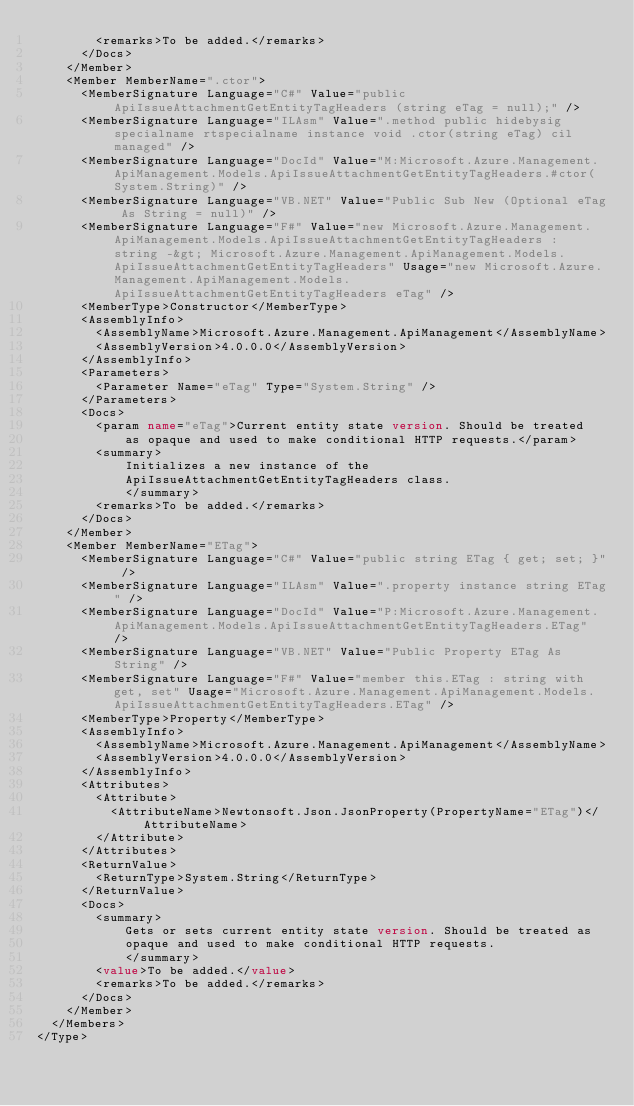Convert code to text. <code><loc_0><loc_0><loc_500><loc_500><_XML_>        <remarks>To be added.</remarks>
      </Docs>
    </Member>
    <Member MemberName=".ctor">
      <MemberSignature Language="C#" Value="public ApiIssueAttachmentGetEntityTagHeaders (string eTag = null);" />
      <MemberSignature Language="ILAsm" Value=".method public hidebysig specialname rtspecialname instance void .ctor(string eTag) cil managed" />
      <MemberSignature Language="DocId" Value="M:Microsoft.Azure.Management.ApiManagement.Models.ApiIssueAttachmentGetEntityTagHeaders.#ctor(System.String)" />
      <MemberSignature Language="VB.NET" Value="Public Sub New (Optional eTag As String = null)" />
      <MemberSignature Language="F#" Value="new Microsoft.Azure.Management.ApiManagement.Models.ApiIssueAttachmentGetEntityTagHeaders : string -&gt; Microsoft.Azure.Management.ApiManagement.Models.ApiIssueAttachmentGetEntityTagHeaders" Usage="new Microsoft.Azure.Management.ApiManagement.Models.ApiIssueAttachmentGetEntityTagHeaders eTag" />
      <MemberType>Constructor</MemberType>
      <AssemblyInfo>
        <AssemblyName>Microsoft.Azure.Management.ApiManagement</AssemblyName>
        <AssemblyVersion>4.0.0.0</AssemblyVersion>
      </AssemblyInfo>
      <Parameters>
        <Parameter Name="eTag" Type="System.String" />
      </Parameters>
      <Docs>
        <param name="eTag">Current entity state version. Should be treated
            as opaque and used to make conditional HTTP requests.</param>
        <summary>
            Initializes a new instance of the
            ApiIssueAttachmentGetEntityTagHeaders class.
            </summary>
        <remarks>To be added.</remarks>
      </Docs>
    </Member>
    <Member MemberName="ETag">
      <MemberSignature Language="C#" Value="public string ETag { get; set; }" />
      <MemberSignature Language="ILAsm" Value=".property instance string ETag" />
      <MemberSignature Language="DocId" Value="P:Microsoft.Azure.Management.ApiManagement.Models.ApiIssueAttachmentGetEntityTagHeaders.ETag" />
      <MemberSignature Language="VB.NET" Value="Public Property ETag As String" />
      <MemberSignature Language="F#" Value="member this.ETag : string with get, set" Usage="Microsoft.Azure.Management.ApiManagement.Models.ApiIssueAttachmentGetEntityTagHeaders.ETag" />
      <MemberType>Property</MemberType>
      <AssemblyInfo>
        <AssemblyName>Microsoft.Azure.Management.ApiManagement</AssemblyName>
        <AssemblyVersion>4.0.0.0</AssemblyVersion>
      </AssemblyInfo>
      <Attributes>
        <Attribute>
          <AttributeName>Newtonsoft.Json.JsonProperty(PropertyName="ETag")</AttributeName>
        </Attribute>
      </Attributes>
      <ReturnValue>
        <ReturnType>System.String</ReturnType>
      </ReturnValue>
      <Docs>
        <summary>
            Gets or sets current entity state version. Should be treated as
            opaque and used to make conditional HTTP requests.
            </summary>
        <value>To be added.</value>
        <remarks>To be added.</remarks>
      </Docs>
    </Member>
  </Members>
</Type>
</code> 